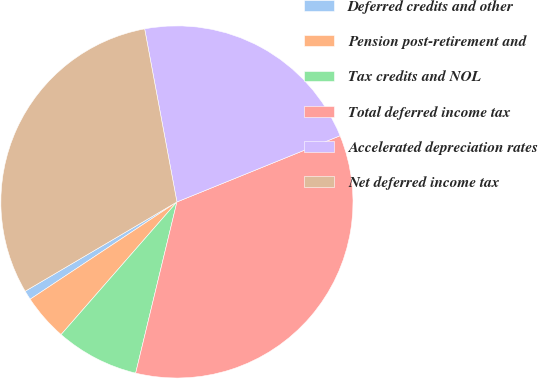Convert chart. <chart><loc_0><loc_0><loc_500><loc_500><pie_chart><fcel>Deferred credits and other<fcel>Pension post-retirement and<fcel>Tax credits and NOL<fcel>Total deferred income tax<fcel>Accelerated depreciation rates<fcel>Net deferred income tax<nl><fcel>0.85%<fcel>4.26%<fcel>7.66%<fcel>34.9%<fcel>21.8%<fcel>30.53%<nl></chart> 